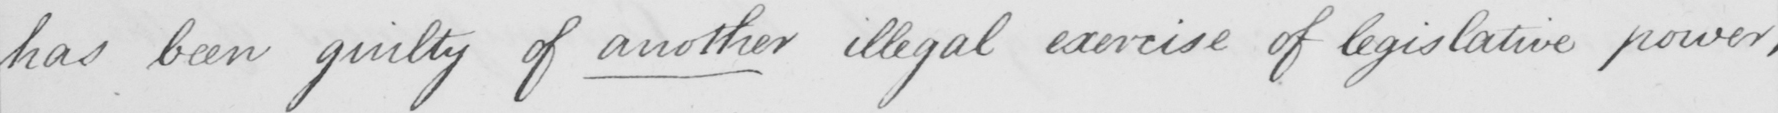Please transcribe the handwritten text in this image. has been guilty of another illegal exercise of legislative power , 